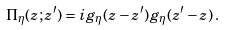Convert formula to latex. <formula><loc_0><loc_0><loc_500><loc_500>\Pi _ { \eta } ( z ; z ^ { \prime } ) = i g _ { \eta } ( z - z ^ { \prime } ) g _ { \eta } ( z ^ { \prime } - z ) \, .</formula> 